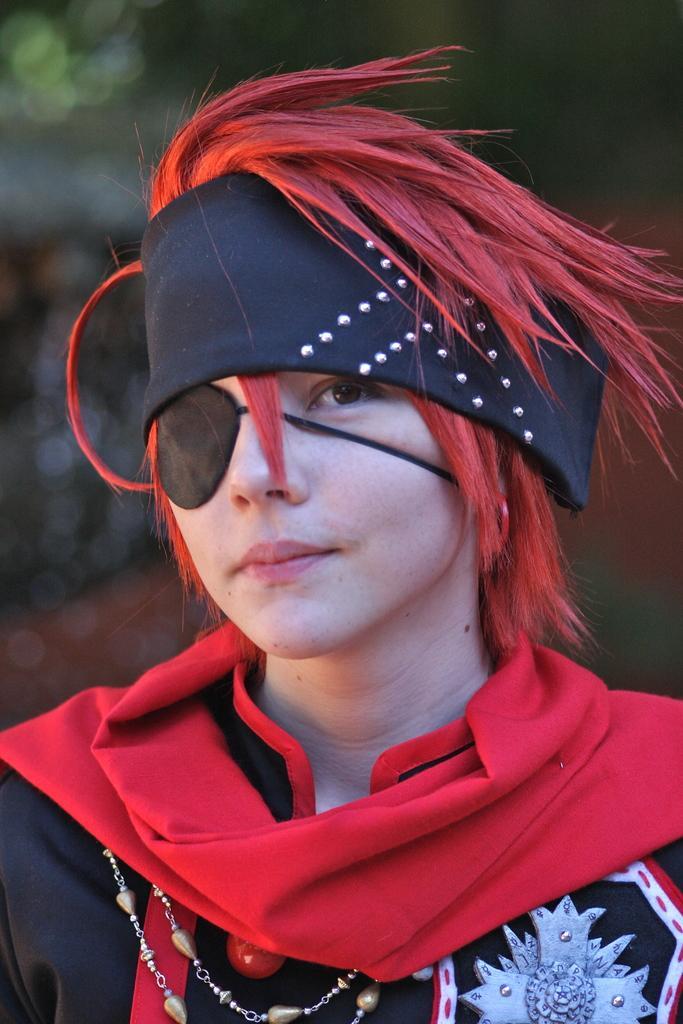Describe this image in one or two sentences. In this image we can see a person wearing a costume with red hair and a black kerchief tied on hi head. 